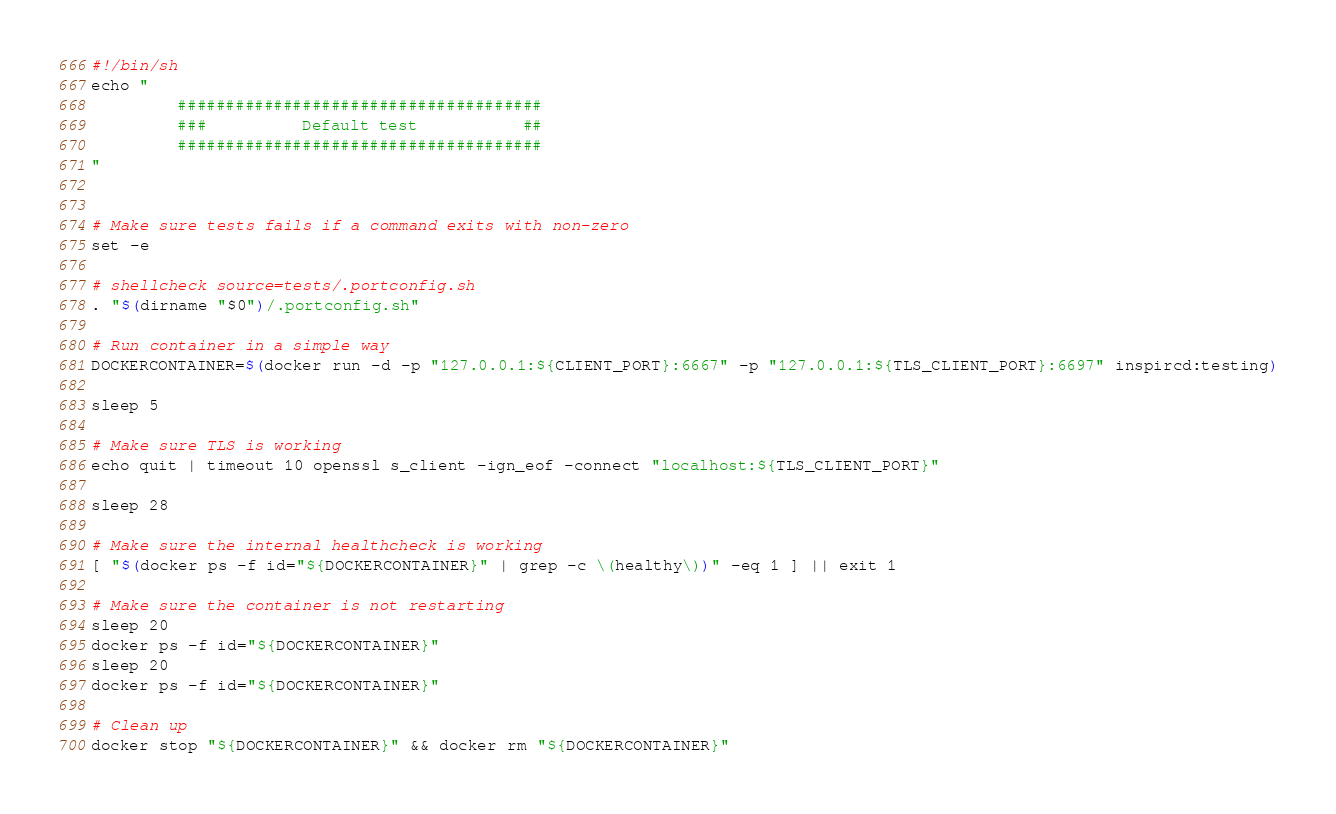Convert code to text. <code><loc_0><loc_0><loc_500><loc_500><_Bash_>#!/bin/sh
echo "
         ######################################
         ###          Default test           ##
         ######################################
"


# Make sure tests fails if a command exits with non-zero
set -e

# shellcheck source=tests/.portconfig.sh
. "$(dirname "$0")/.portconfig.sh"

# Run container in a simple way
DOCKERCONTAINER=$(docker run -d -p "127.0.0.1:${CLIENT_PORT}:6667" -p "127.0.0.1:${TLS_CLIENT_PORT}:6697" inspircd:testing)

sleep 5

# Make sure TLS is working
echo quit | timeout 10 openssl s_client -ign_eof -connect "localhost:${TLS_CLIENT_PORT}"

sleep 28

# Make sure the internal healthcheck is working
[ "$(docker ps -f id="${DOCKERCONTAINER}" | grep -c \(healthy\))" -eq 1 ] || exit 1

# Make sure the container is not restarting
sleep 20
docker ps -f id="${DOCKERCONTAINER}"
sleep 20
docker ps -f id="${DOCKERCONTAINER}"

# Clean up
docker stop "${DOCKERCONTAINER}" && docker rm "${DOCKERCONTAINER}"
</code> 